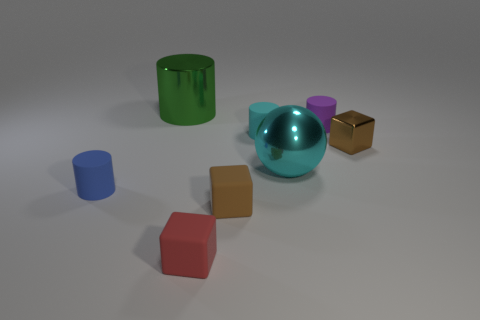Subtract all purple cylinders. How many cylinders are left? 3 Subtract 1 cylinders. How many cylinders are left? 3 Subtract all balls. How many objects are left? 7 Add 2 blue cubes. How many objects exist? 10 Subtract all purple spheres. How many purple cylinders are left? 1 Subtract all cyan things. Subtract all cyan matte cylinders. How many objects are left? 5 Add 4 cyan things. How many cyan things are left? 6 Add 7 big red matte cubes. How many big red matte cubes exist? 7 Subtract all red blocks. How many blocks are left? 2 Subtract 0 blue cubes. How many objects are left? 8 